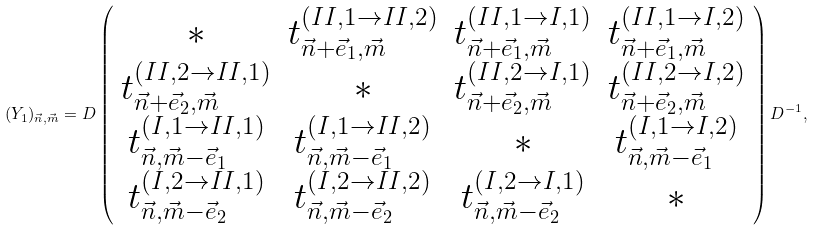Convert formula to latex. <formula><loc_0><loc_0><loc_500><loc_500>( Y _ { 1 } ) _ { \vec { n } , \vec { m } } = D \left ( \begin{array} { c c c c } * & t _ { \vec { n } + \vec { e } _ { 1 } , \vec { m } } ^ { ( I I , 1 \to I I , 2 ) } & t _ { \vec { n } + \vec { e } _ { 1 } , \vec { m } } ^ { ( I I , 1 \to I , 1 ) } & t _ { \vec { n } + \vec { e } _ { 1 } , \vec { m } } ^ { ( I I , 1 \to I , 2 ) } \\ t _ { \vec { n } + \vec { e } _ { 2 } , \vec { m } } ^ { ( I I , 2 \to I I , 1 ) } & * & t _ { \vec { n } + \vec { e } _ { 2 } , \vec { m } } ^ { ( I I , 2 \to I , 1 ) } & t _ { \vec { n } + \vec { e } _ { 2 } , \vec { m } } ^ { ( I I , 2 \to I , 2 ) } \\ t _ { \vec { n } , \vec { m } - \vec { e } _ { 1 } } ^ { ( I , 1 \to I I , 1 ) } & t _ { \vec { n } , \vec { m } - \vec { e } _ { 1 } } ^ { ( I , 1 \to I I , 2 ) } & * & t _ { \vec { n } , \vec { m } - \vec { e } _ { 1 } } ^ { ( I , 1 \to I , 2 ) } \\ t _ { \vec { n } , \vec { m } - \vec { e } _ { 2 } } ^ { ( I , 2 \to I I , 1 ) } & t _ { \vec { n } , \vec { m } - \vec { e } _ { 2 } } ^ { ( I , 2 \to I I , 2 ) } & t _ { \vec { n } , \vec { m } - \vec { e } _ { 2 } } ^ { ( I , 2 \to I , 1 ) } & * \end{array} \right ) D ^ { - 1 } ,</formula> 